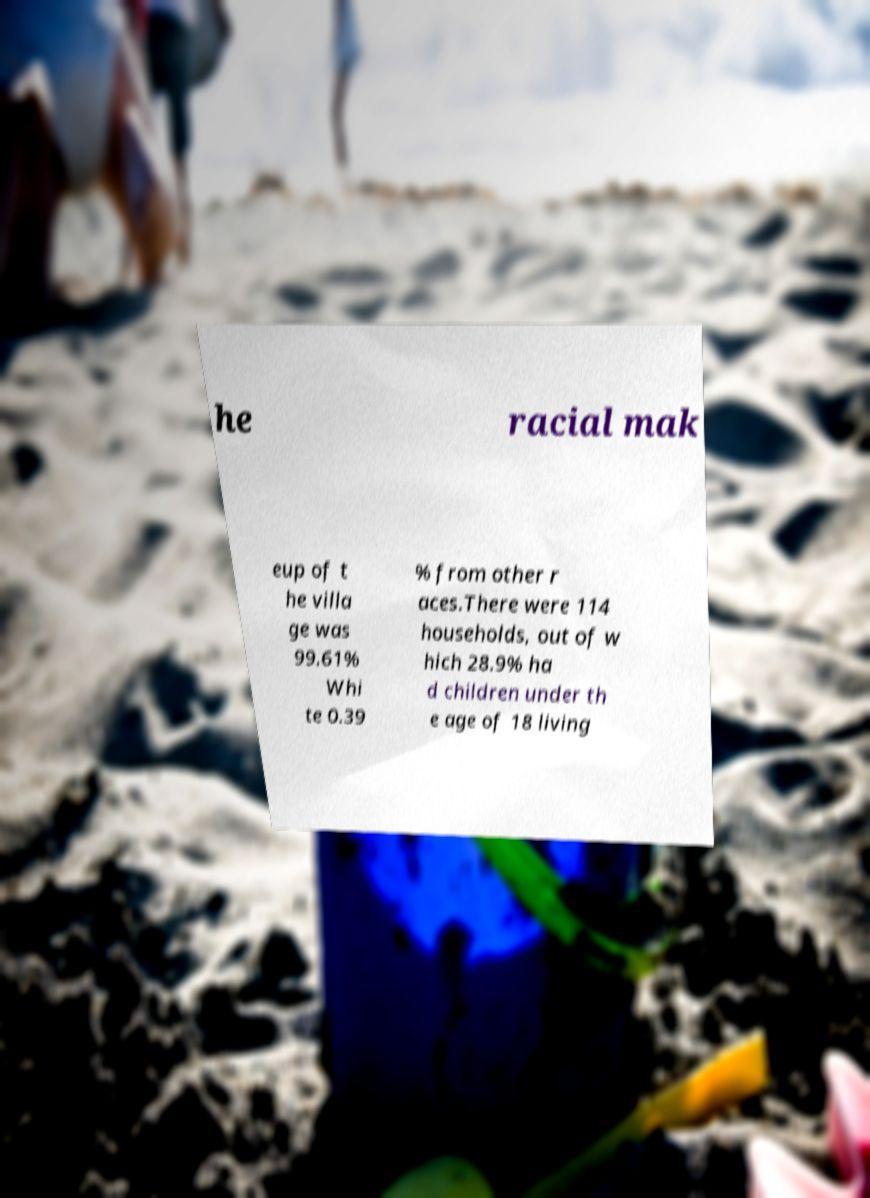Could you assist in decoding the text presented in this image and type it out clearly? he racial mak eup of t he villa ge was 99.61% Whi te 0.39 % from other r aces.There were 114 households, out of w hich 28.9% ha d children under th e age of 18 living 